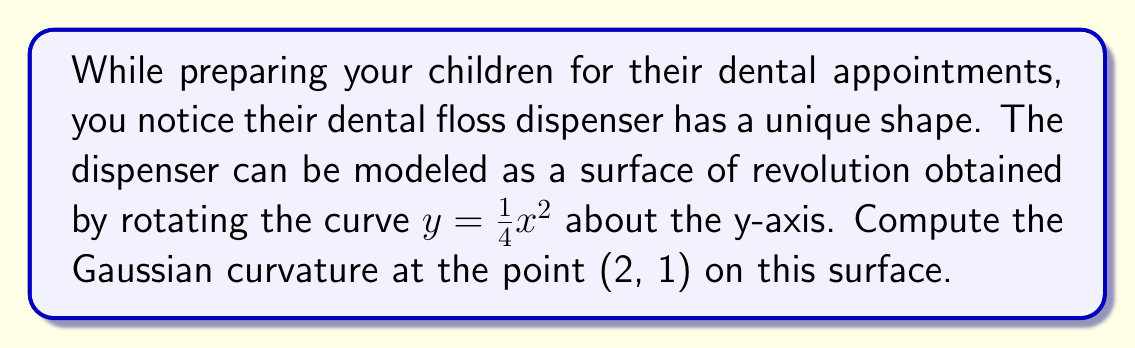Can you solve this math problem? Let's approach this step-by-step:

1) For a surface of revolution obtained by rotating $y = f(x)$ about the y-axis, we can use the parametrization:
   $r(u,v) = (u\cos v, u\sin v, f(u))$

2) In our case, $f(u) = \frac{1}{4}u^2$

3) To compute the Gaussian curvature, we need to calculate the coefficients of the first and second fundamental forms:

   $E = \langle r_u, r_u \rangle = 1 + (f'(u))^2 = 1 + u^2$
   $F = \langle r_u, r_v \rangle = 0$
   $G = \langle r_v, r_v \rangle = u^2$

   $L = \frac{f''(u)}{\sqrt{1+(f'(u))^2}} = \frac{\frac{1}{2}}{\sqrt{1+u^2}}$
   $M = 0$
   $N = \frac{uf'(u)}{\sqrt{1+(f'(u))^2}} = \frac{u^2}{\sqrt{1+u^2}}$

4) The Gaussian curvature is given by:
   $K = \frac{LN - M^2}{EG - F^2}$

5) Substituting our values:
   $K = \frac{\frac{\frac{1}{2}}{\sqrt{1+u^2}} \cdot \frac{u^2}{\sqrt{1+u^2}} - 0^2}{(1+u^2)u^2 - 0^2}$

6) Simplifying:
   $K = \frac{\frac{u^2}{2(1+u^2)}}{u^2(1+u^2)} = \frac{1}{2u^2(1+u^2)}$

7) At the point (2, 1), $u = 2$. Substituting this:
   $K = \frac{1}{2(2^2)(1+2^2)} = \frac{1}{2(4)(5)} = \frac{1}{40}$

Therefore, the Gaussian curvature at the point (2, 1) is $\frac{1}{40}$.
Answer: $\frac{1}{40}$ 